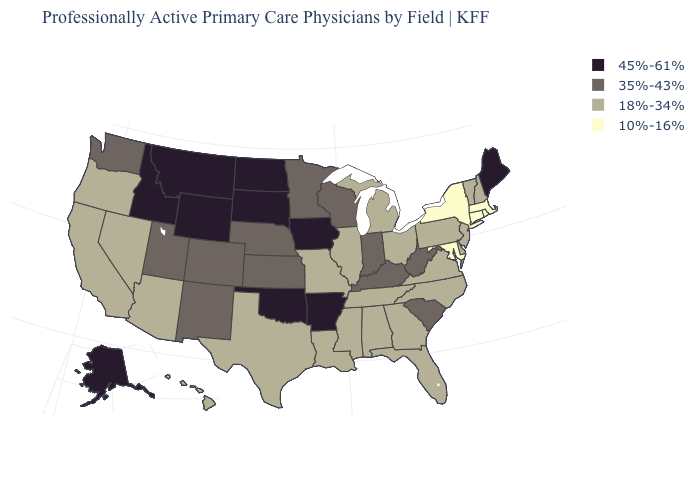Among the states that border Wyoming , which have the highest value?
Answer briefly. Idaho, Montana, South Dakota. How many symbols are there in the legend?
Keep it brief. 4. What is the value of Michigan?
Give a very brief answer. 18%-34%. Name the states that have a value in the range 18%-34%?
Give a very brief answer. Alabama, Arizona, California, Delaware, Florida, Georgia, Hawaii, Illinois, Louisiana, Michigan, Mississippi, Missouri, Nevada, New Hampshire, New Jersey, North Carolina, Ohio, Oregon, Pennsylvania, Tennessee, Texas, Vermont, Virginia. Which states have the highest value in the USA?
Be succinct. Alaska, Arkansas, Idaho, Iowa, Maine, Montana, North Dakota, Oklahoma, South Dakota, Wyoming. Name the states that have a value in the range 35%-43%?
Concise answer only. Colorado, Indiana, Kansas, Kentucky, Minnesota, Nebraska, New Mexico, South Carolina, Utah, Washington, West Virginia, Wisconsin. What is the value of Tennessee?
Short answer required. 18%-34%. What is the lowest value in states that border Kansas?
Short answer required. 18%-34%. Does Delaware have the same value as Maryland?
Quick response, please. No. Does Alaska have the lowest value in the USA?
Give a very brief answer. No. Which states have the lowest value in the MidWest?
Answer briefly. Illinois, Michigan, Missouri, Ohio. What is the lowest value in states that border New Jersey?
Keep it brief. 10%-16%. Does Maine have the highest value in the Northeast?
Write a very short answer. Yes. Name the states that have a value in the range 18%-34%?
Give a very brief answer. Alabama, Arizona, California, Delaware, Florida, Georgia, Hawaii, Illinois, Louisiana, Michigan, Mississippi, Missouri, Nevada, New Hampshire, New Jersey, North Carolina, Ohio, Oregon, Pennsylvania, Tennessee, Texas, Vermont, Virginia. Name the states that have a value in the range 35%-43%?
Quick response, please. Colorado, Indiana, Kansas, Kentucky, Minnesota, Nebraska, New Mexico, South Carolina, Utah, Washington, West Virginia, Wisconsin. 